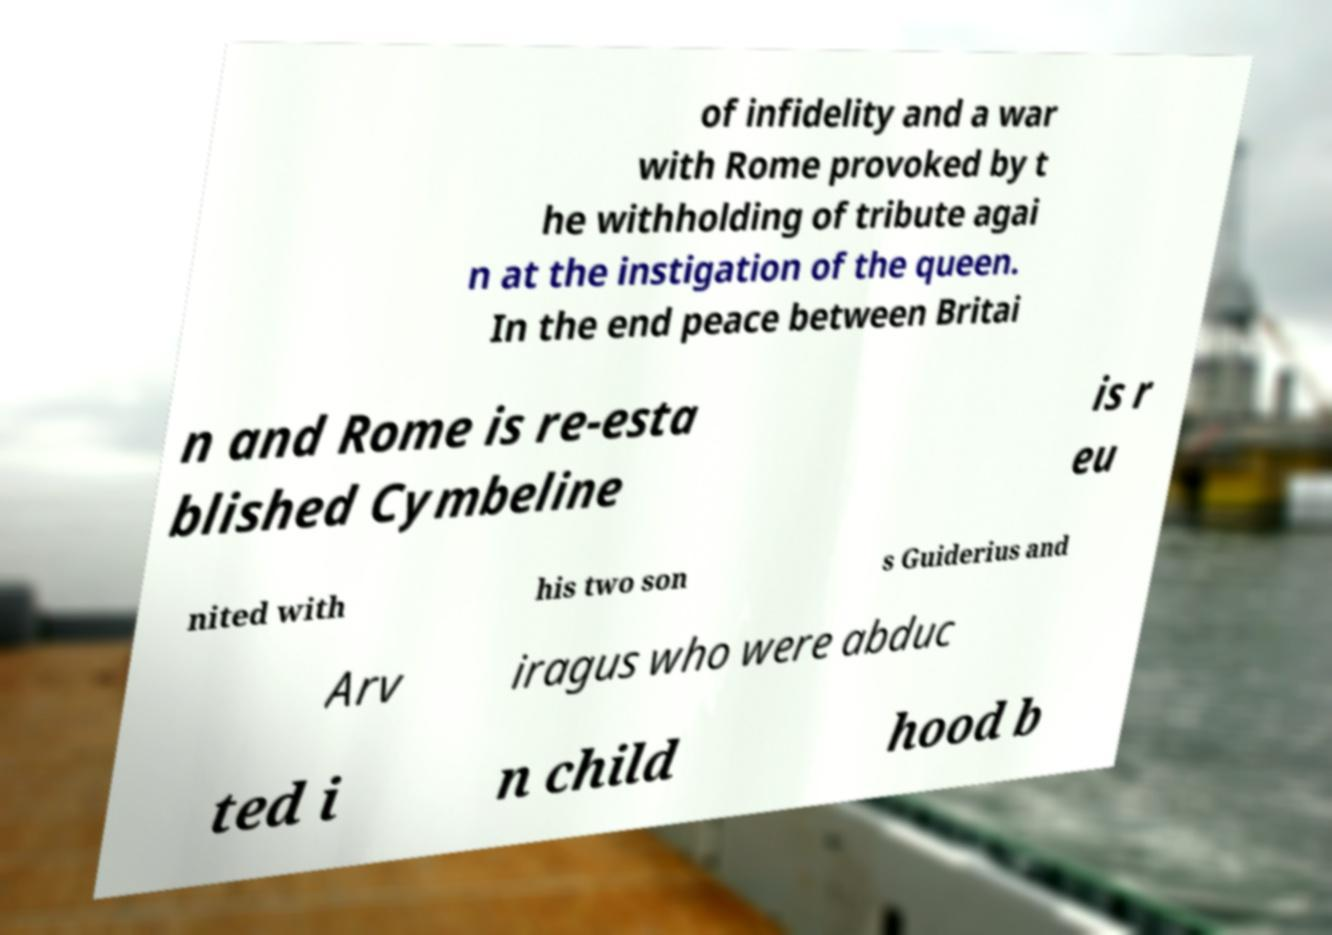For documentation purposes, I need the text within this image transcribed. Could you provide that? of infidelity and a war with Rome provoked by t he withholding of tribute agai n at the instigation of the queen. In the end peace between Britai n and Rome is re-esta blished Cymbeline is r eu nited with his two son s Guiderius and Arv iragus who were abduc ted i n child hood b 